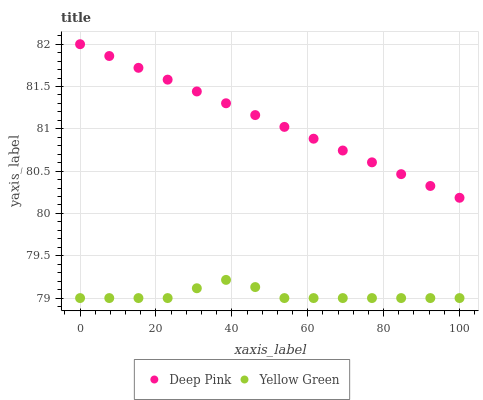Does Yellow Green have the minimum area under the curve?
Answer yes or no. Yes. Does Deep Pink have the maximum area under the curve?
Answer yes or no. Yes. Does Yellow Green have the maximum area under the curve?
Answer yes or no. No. Is Deep Pink the smoothest?
Answer yes or no. Yes. Is Yellow Green the roughest?
Answer yes or no. Yes. Is Yellow Green the smoothest?
Answer yes or no. No. Does Yellow Green have the lowest value?
Answer yes or no. Yes. Does Deep Pink have the highest value?
Answer yes or no. Yes. Does Yellow Green have the highest value?
Answer yes or no. No. Is Yellow Green less than Deep Pink?
Answer yes or no. Yes. Is Deep Pink greater than Yellow Green?
Answer yes or no. Yes. Does Yellow Green intersect Deep Pink?
Answer yes or no. No. 